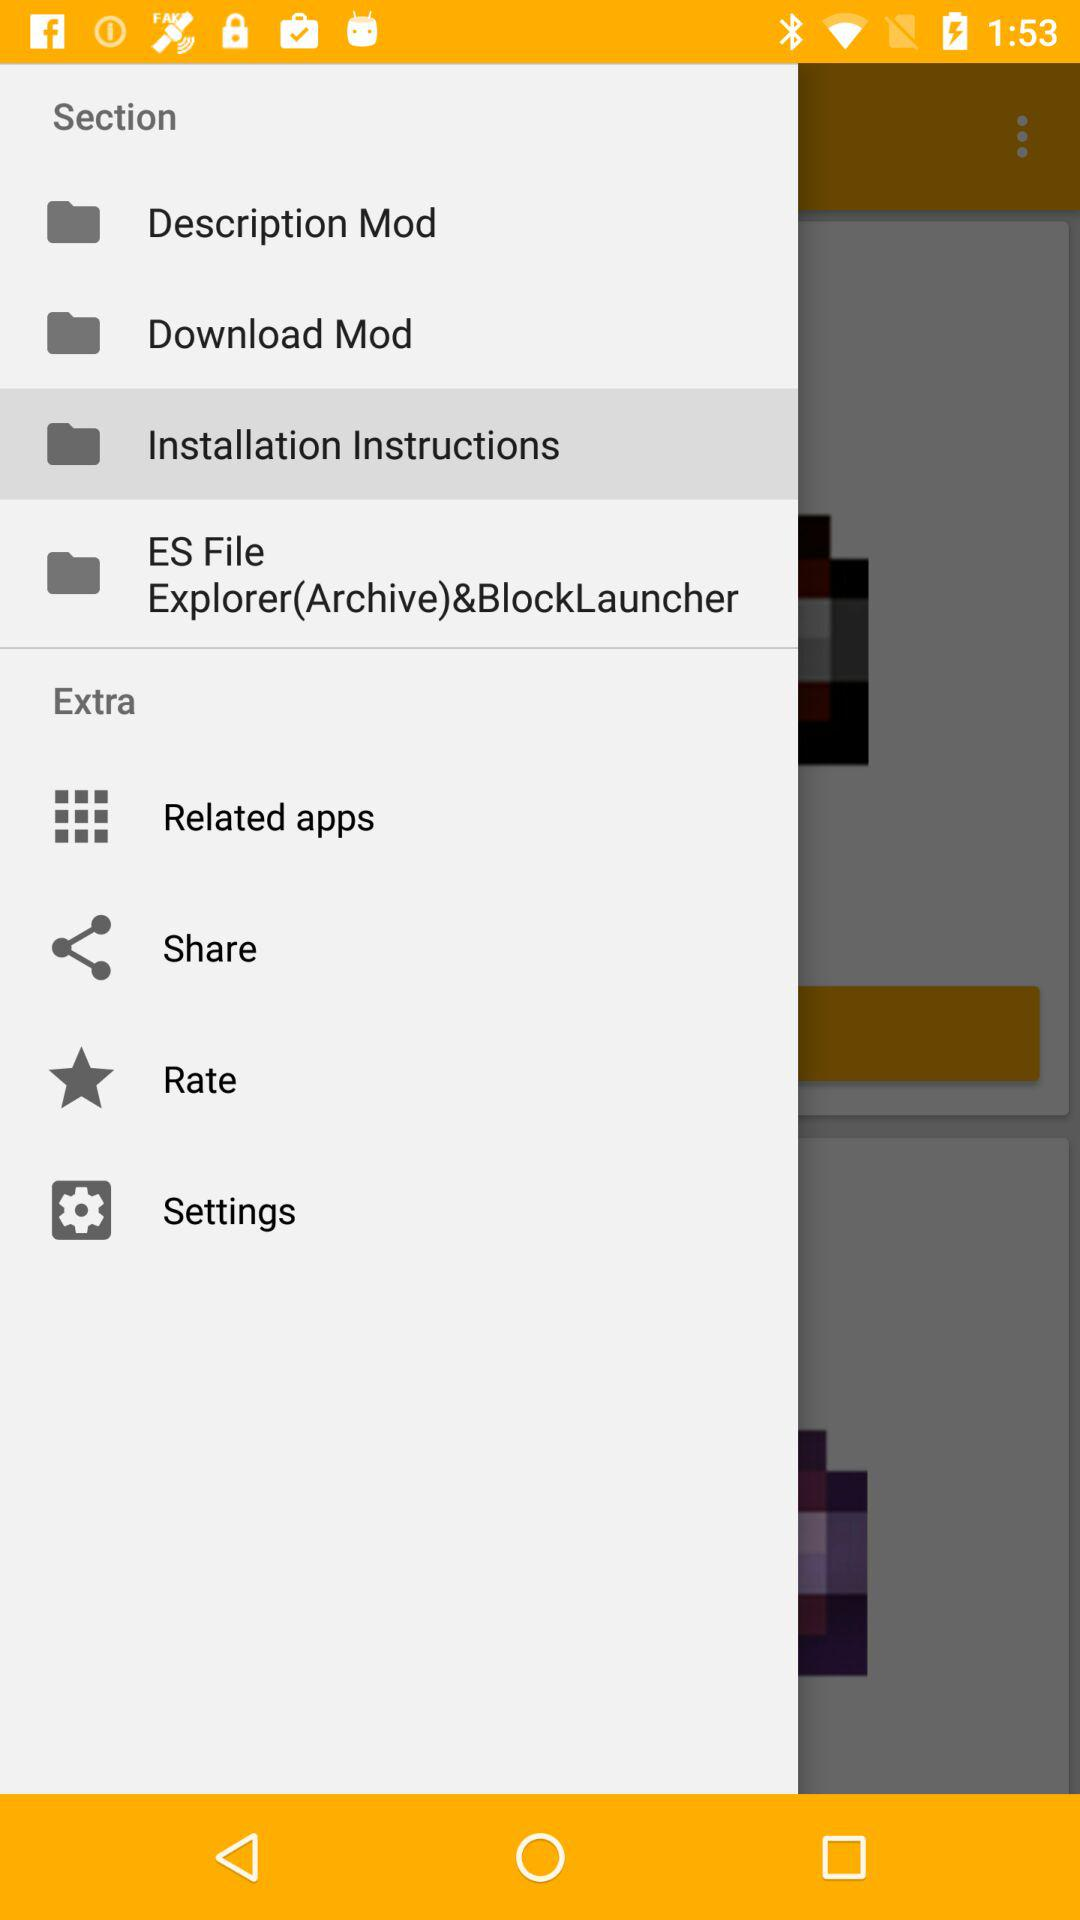Which is the selected item in the menu? The selected item in the menu is "Installation Instructions". 